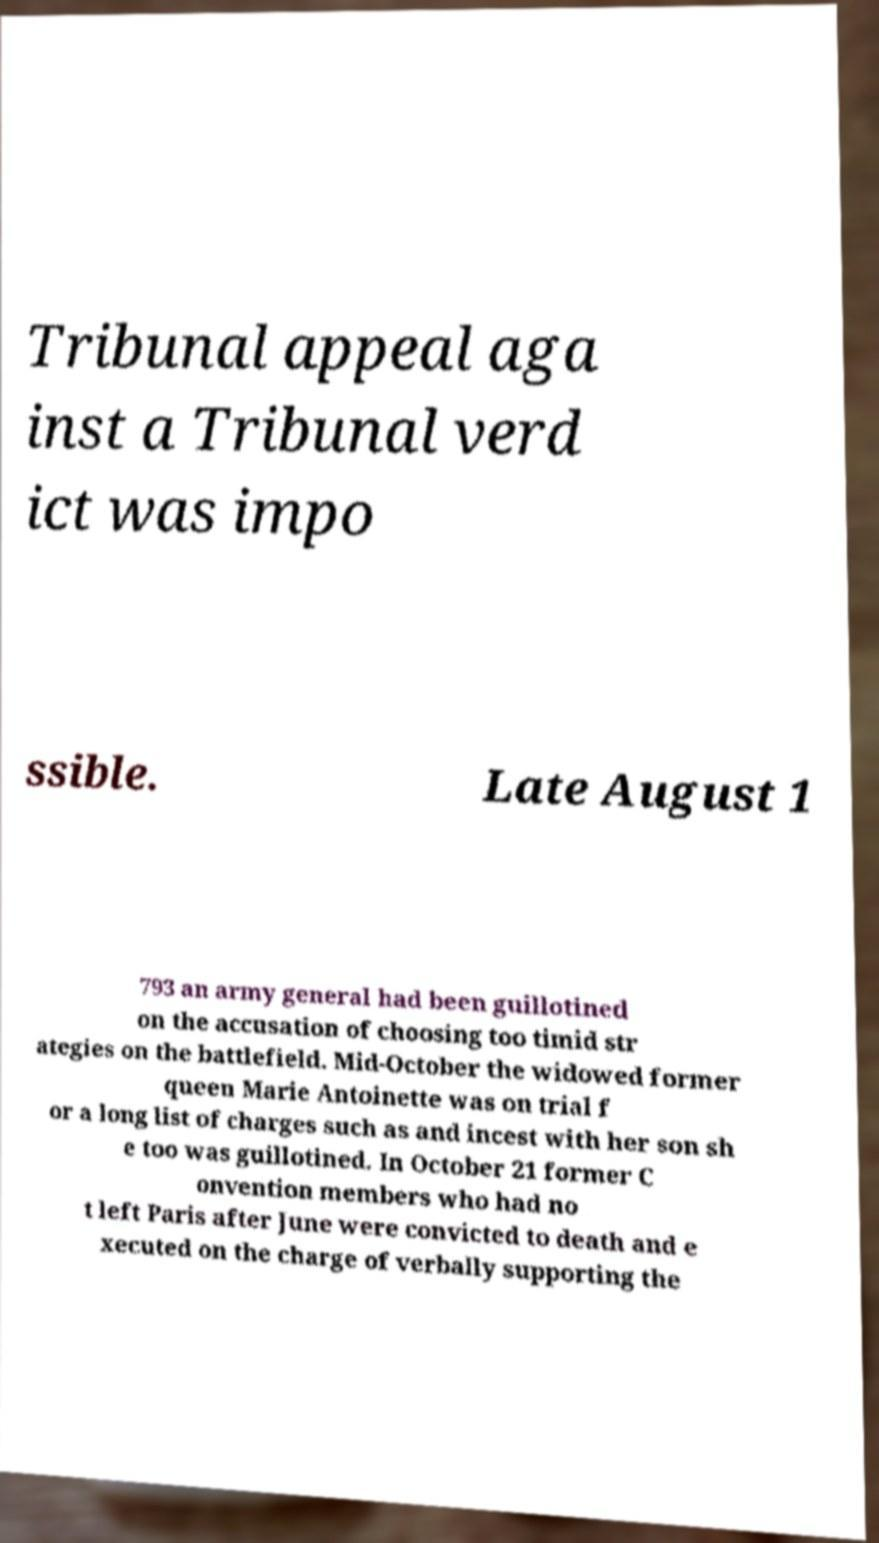Could you assist in decoding the text presented in this image and type it out clearly? Tribunal appeal aga inst a Tribunal verd ict was impo ssible. Late August 1 793 an army general had been guillotined on the accusation of choosing too timid str ategies on the battlefield. Mid-October the widowed former queen Marie Antoinette was on trial f or a long list of charges such as and incest with her son sh e too was guillotined. In October 21 former C onvention members who had no t left Paris after June were convicted to death and e xecuted on the charge of verbally supporting the 